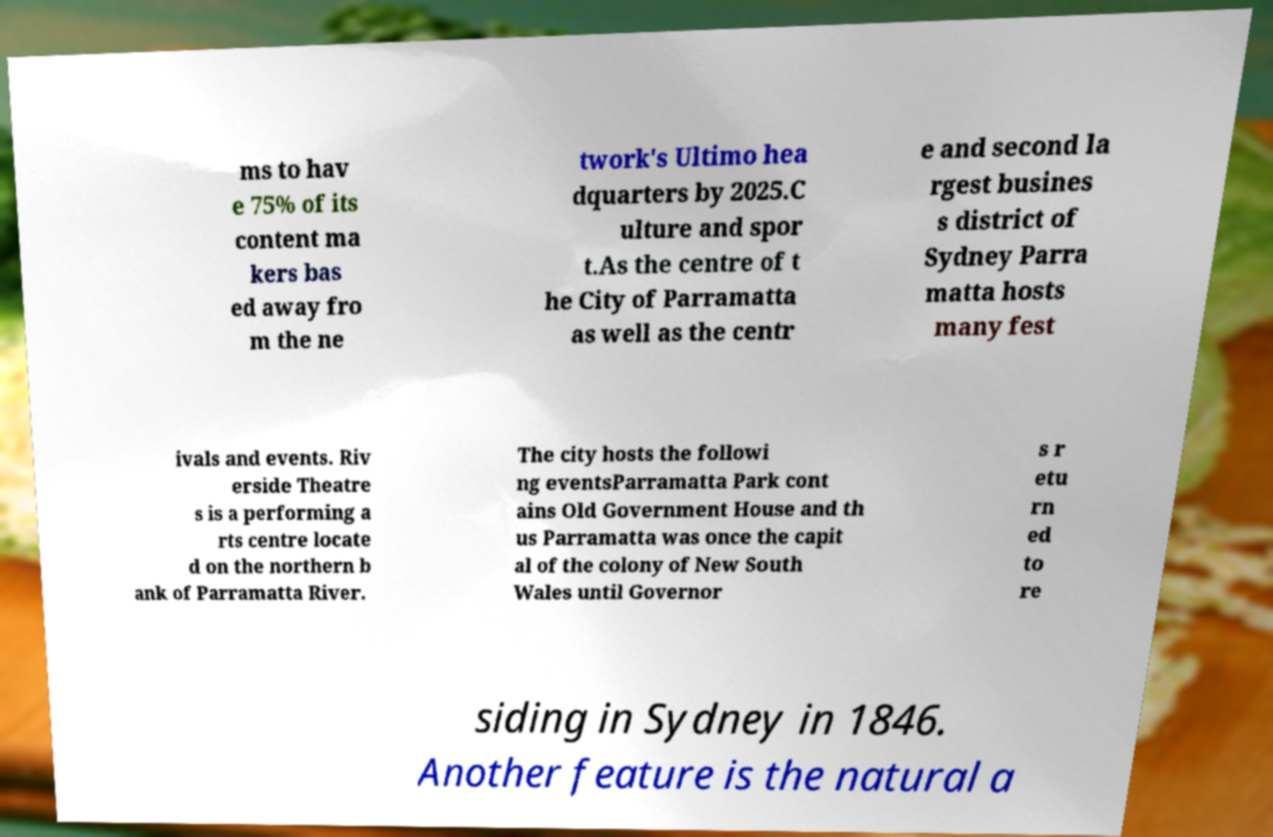Could you assist in decoding the text presented in this image and type it out clearly? ms to hav e 75% of its content ma kers bas ed away fro m the ne twork's Ultimo hea dquarters by 2025.C ulture and spor t.As the centre of t he City of Parramatta as well as the centr e and second la rgest busines s district of Sydney Parra matta hosts many fest ivals and events. Riv erside Theatre s is a performing a rts centre locate d on the northern b ank of Parramatta River. The city hosts the followi ng eventsParramatta Park cont ains Old Government House and th us Parramatta was once the capit al of the colony of New South Wales until Governor s r etu rn ed to re siding in Sydney in 1846. Another feature is the natural a 